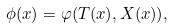<formula> <loc_0><loc_0><loc_500><loc_500>\phi ( x ) = \varphi ( T ( x ) , X ( x ) ) ,</formula> 